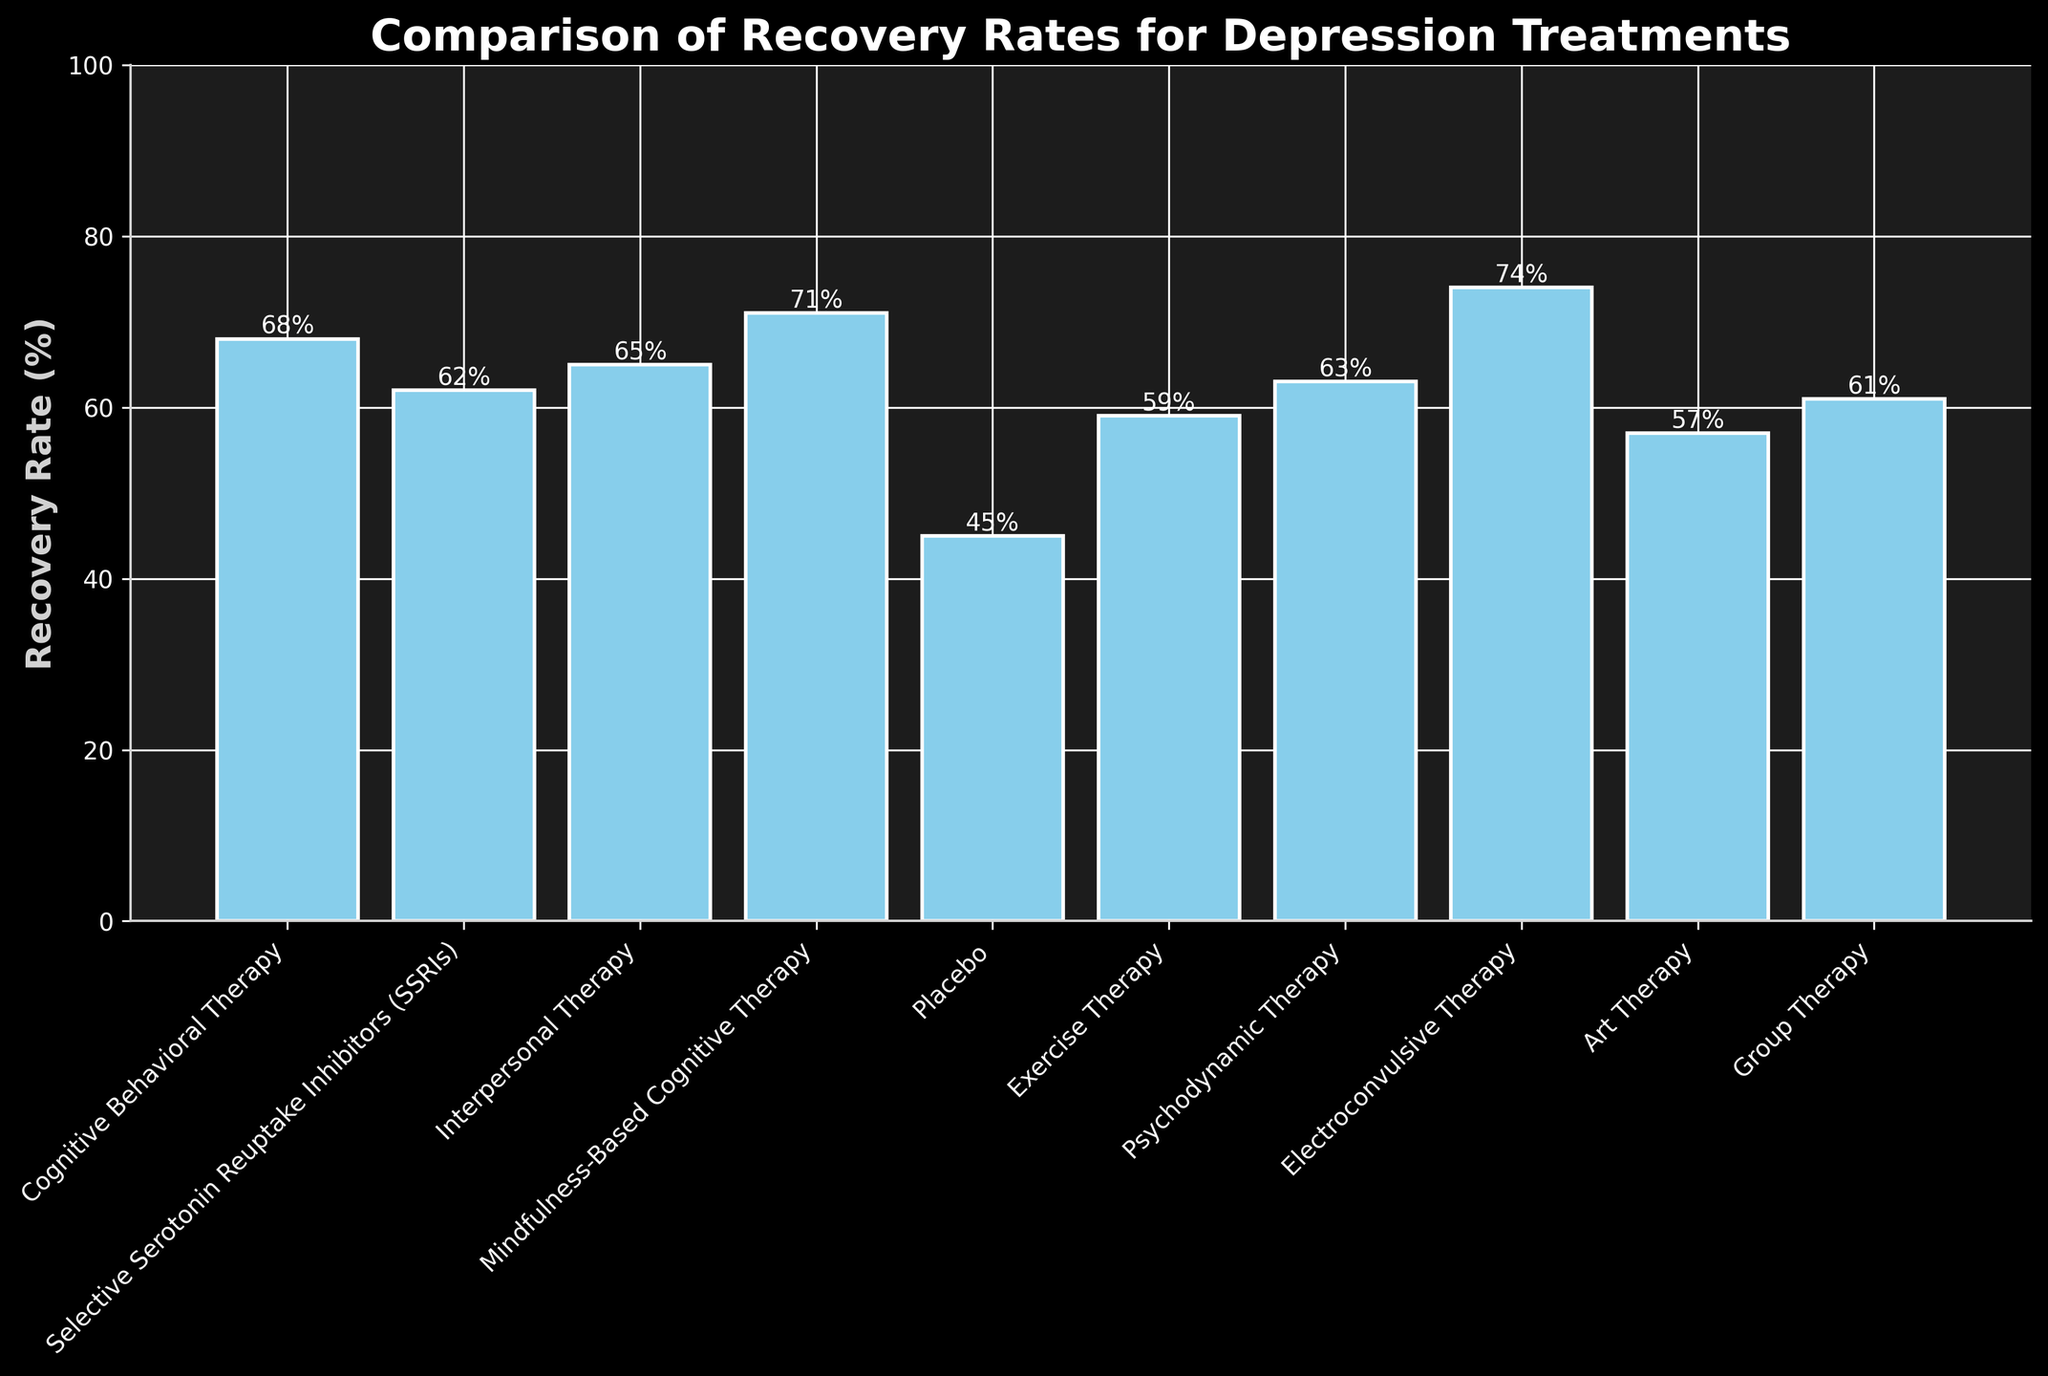What treatment has the highest recovery rate? The bar with the highest height represents the treatment with the highest recovery rate. Electroconvulsive Therapy has the highest bar with a recovery rate of 74%.
Answer: Electroconvulsive Therapy Which treatment has the closest recovery rate to SSRIs? Look for the bars with heights closest to Selective Serotonin Reuptake Inhibitors (SSRIs) which has a recovery rate of 62%. Psychodynamic Therapy has a recovery rate of 63%, which is the closest.
Answer: Psychodynamic Therapy List the treatments with a recovery rate above 65%? Identify the bars with heights above 65%. Those treatments are Cognitive Behavioral Therapy (68%), Mindfulness-Based Cognitive Therapy (71%), and Electroconvulsive Therapy (74%).
Answer: Cognitive Behavioral Therapy, Mindfulness-Based Cognitive Therapy, Electroconvulsive Therapy How much higher is the recovery rate of Mindfulness-Based Cognitive Therapy compared to Placebo? Subtract the recovery rate of Placebo (45%) from the recovery rate of Mindfulness-Based Cognitive Therapy (71%). The calculation is 71% - 45% = 26%.
Answer: 26% What is the average recovery rate of non-medication treatments in this chart? First, sum the recovery rates of non-medication treatments: Cognitive Behavioral Therapy (68%), Interpersonal Therapy (65%), Mindfulness-Based Cognitive Therapy (71%), Exercise Therapy (59%), Psychodynamic Therapy (63%), Art Therapy (57%), Group Therapy (61%). The total is 68 + 65 + 71 + 59 + 63 + 57 + 61 = 444. Divide by the number of treatments (7): 444 / 7 = 63.43.
Answer: 63.43% Does any treatment have a recovery rate between 50% and 60%? Check the bars to see if any have heights representing recovery rates within the range of 50% to 60%. Exercise Therapy (59%) and Art Therapy (57%) fall within this range.
Answer: Exercise Therapy, Art Therapy Are there any treatments with equal recovery rates? Compare recovery rates of different treatments to see if any are equal. No treatments have the exact same recovery rate in the given data.
Answer: No Which treatment has the lowest recovery rate? The bar with the smallest height represents the treatment with the lowest recovery rate. Placebo has the lowest recovery rate at 45%.
Answer: Placebo 